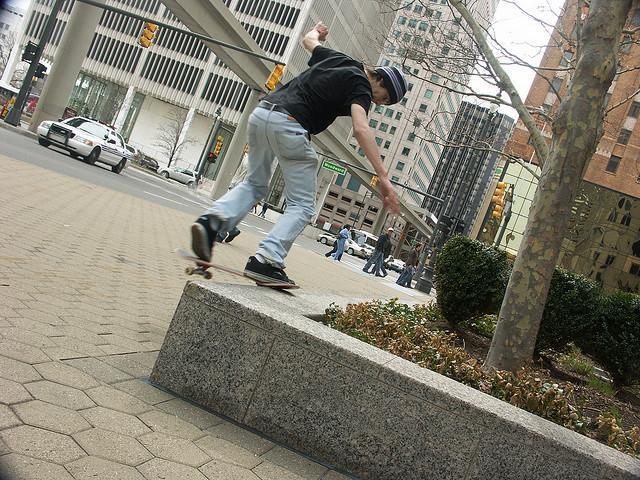How many people can you see?
Give a very brief answer. 1. 